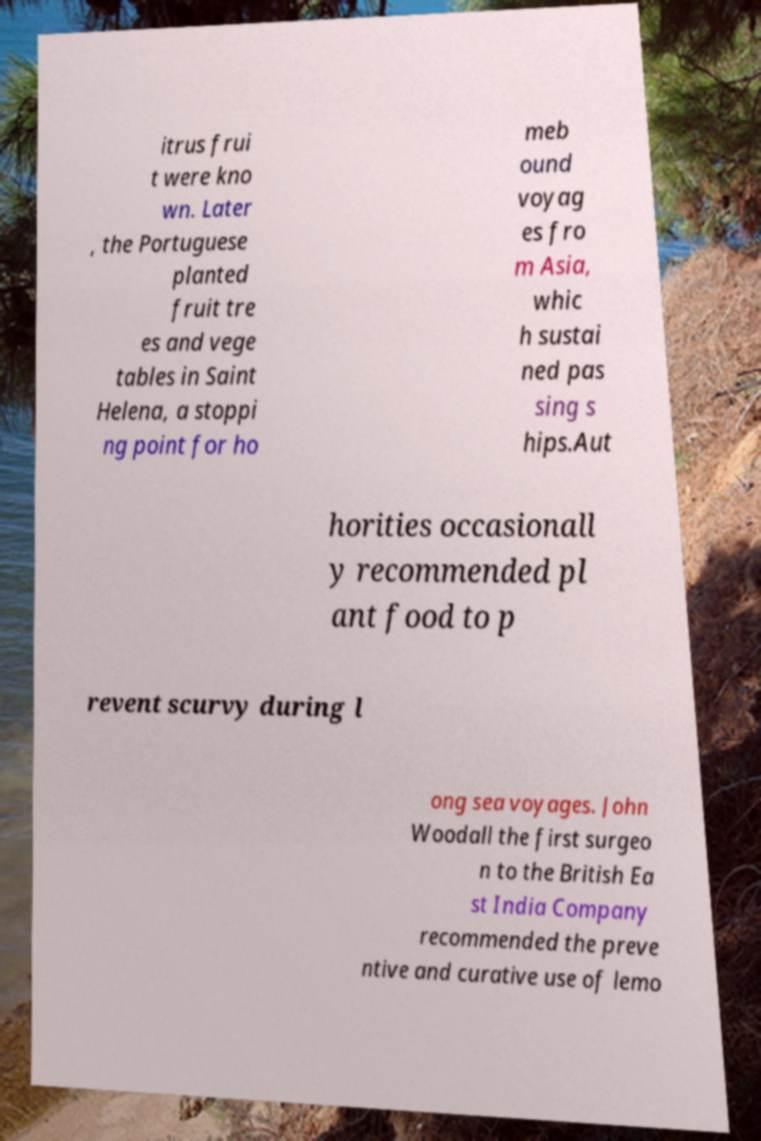Can you read and provide the text displayed in the image?This photo seems to have some interesting text. Can you extract and type it out for me? itrus frui t were kno wn. Later , the Portuguese planted fruit tre es and vege tables in Saint Helena, a stoppi ng point for ho meb ound voyag es fro m Asia, whic h sustai ned pas sing s hips.Aut horities occasionall y recommended pl ant food to p revent scurvy during l ong sea voyages. John Woodall the first surgeo n to the British Ea st India Company recommended the preve ntive and curative use of lemo 